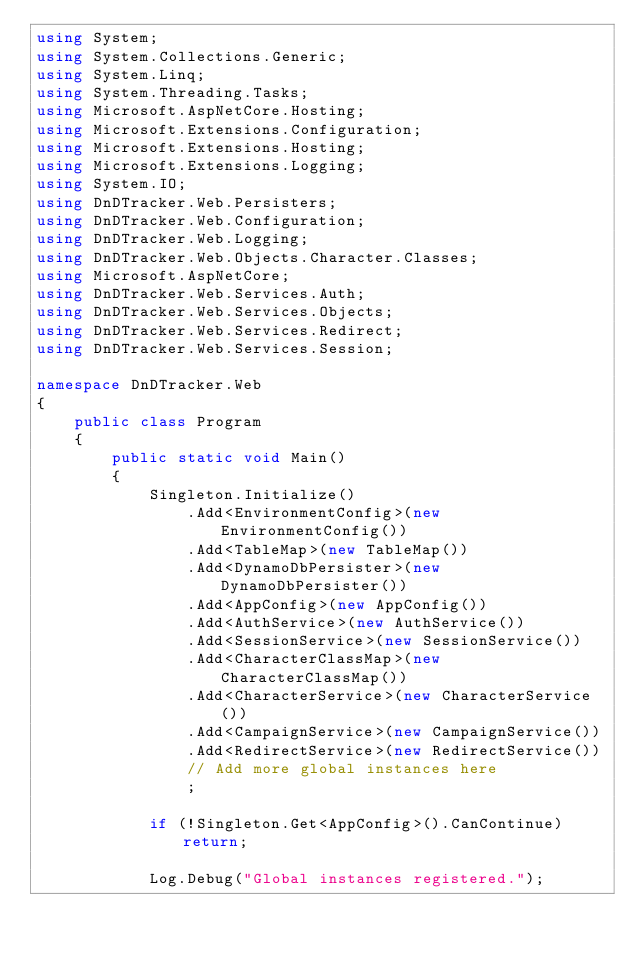<code> <loc_0><loc_0><loc_500><loc_500><_C#_>using System;
using System.Collections.Generic;
using System.Linq;
using System.Threading.Tasks;
using Microsoft.AspNetCore.Hosting;
using Microsoft.Extensions.Configuration;
using Microsoft.Extensions.Hosting;
using Microsoft.Extensions.Logging;
using System.IO;
using DnDTracker.Web.Persisters;
using DnDTracker.Web.Configuration;
using DnDTracker.Web.Logging;
using DnDTracker.Web.Objects.Character.Classes;
using Microsoft.AspNetCore;
using DnDTracker.Web.Services.Auth;
using DnDTracker.Web.Services.Objects;
using DnDTracker.Web.Services.Redirect;
using DnDTracker.Web.Services.Session;

namespace DnDTracker.Web
{
    public class Program
    {
        public static void Main()
        {
            Singleton.Initialize()
                .Add<EnvironmentConfig>(new EnvironmentConfig())
                .Add<TableMap>(new TableMap())
                .Add<DynamoDbPersister>(new DynamoDbPersister())
                .Add<AppConfig>(new AppConfig())
                .Add<AuthService>(new AuthService())
                .Add<SessionService>(new SessionService())
                .Add<CharacterClassMap>(new CharacterClassMap())
                .Add<CharacterService>(new CharacterService())
                .Add<CampaignService>(new CampaignService())
                .Add<RedirectService>(new RedirectService())
                // Add more global instances here
                ;

            if (!Singleton.Get<AppConfig>().CanContinue) return;

            Log.Debug("Global instances registered.");
</code> 